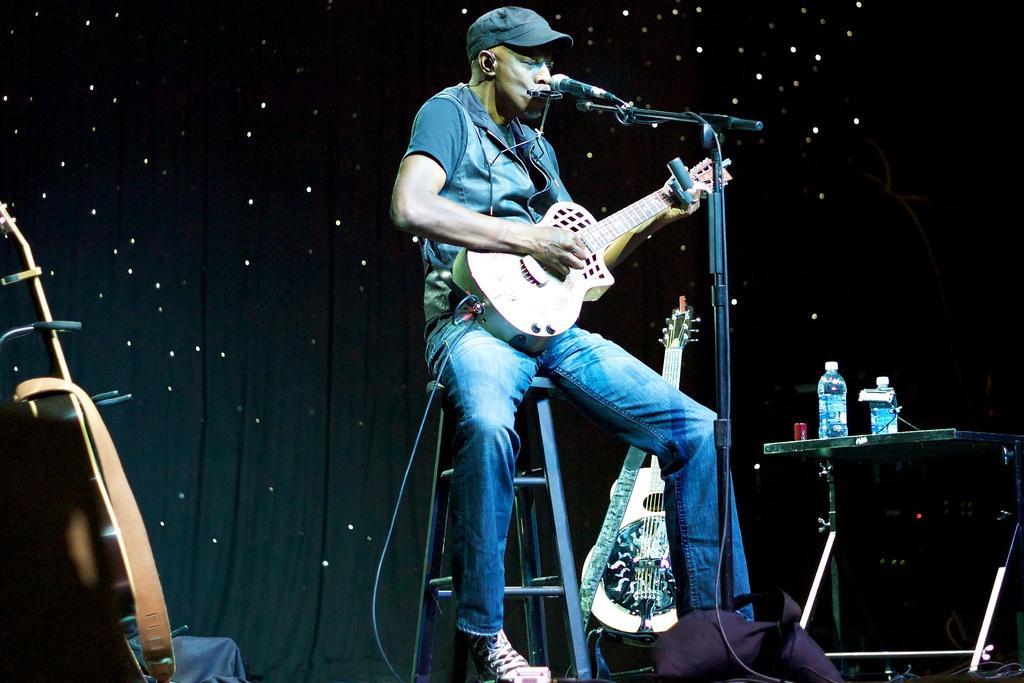In one or two sentences, can you explain what this image depicts? In this image I can see a man sitting on a stool, playing a guitar and also it seems like he's singing a song. There is a mike stand in front of this person. On the right side of the image there is a small table and two bottles are there on it. On the left side I can see a guitar. In the background I can see a black color curtain. 